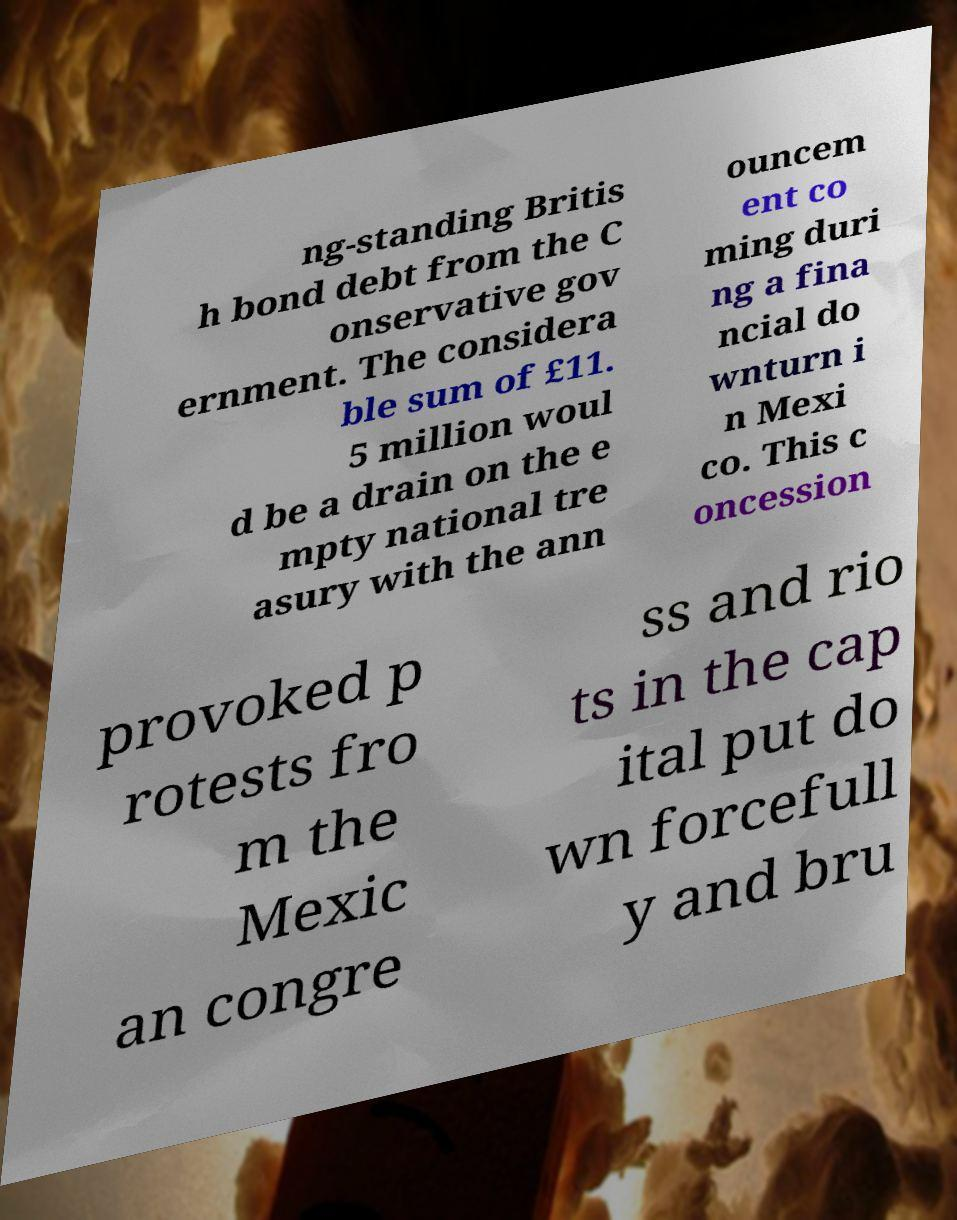I need the written content from this picture converted into text. Can you do that? ng-standing Britis h bond debt from the C onservative gov ernment. The considera ble sum of £11. 5 million woul d be a drain on the e mpty national tre asury with the ann ouncem ent co ming duri ng a fina ncial do wnturn i n Mexi co. This c oncession provoked p rotests fro m the Mexic an congre ss and rio ts in the cap ital put do wn forcefull y and bru 